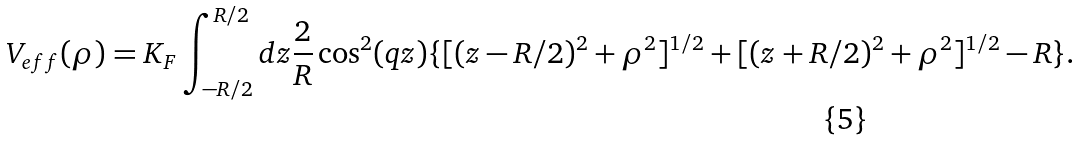<formula> <loc_0><loc_0><loc_500><loc_500>V _ { e f f } ( \rho ) = K _ { F } \int _ { - R / 2 } ^ { R / 2 } d z \frac { 2 } { R } \cos ^ { 2 } ( q z ) \{ [ ( z - R / 2 ) ^ { 2 } + \rho ^ { 2 } ] ^ { 1 / 2 } + [ ( z + R / 2 ) ^ { 2 } + \rho ^ { 2 } ] ^ { 1 / 2 } - R \} .</formula> 